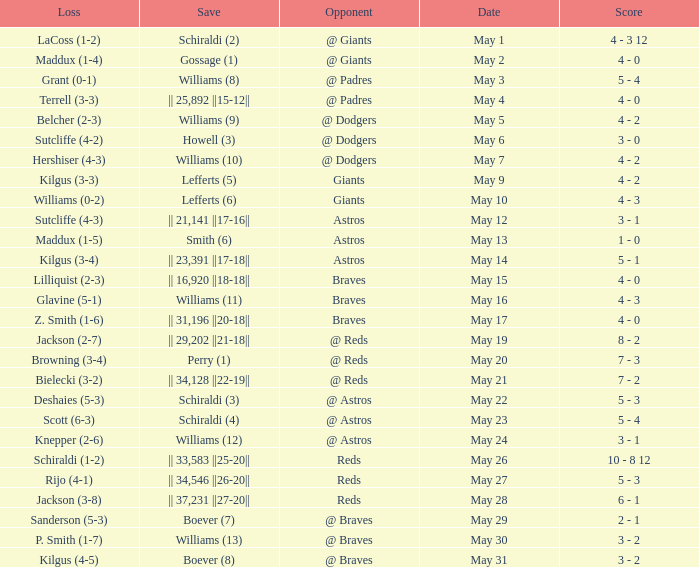Name the loss for may 1 LaCoss (1-2). 